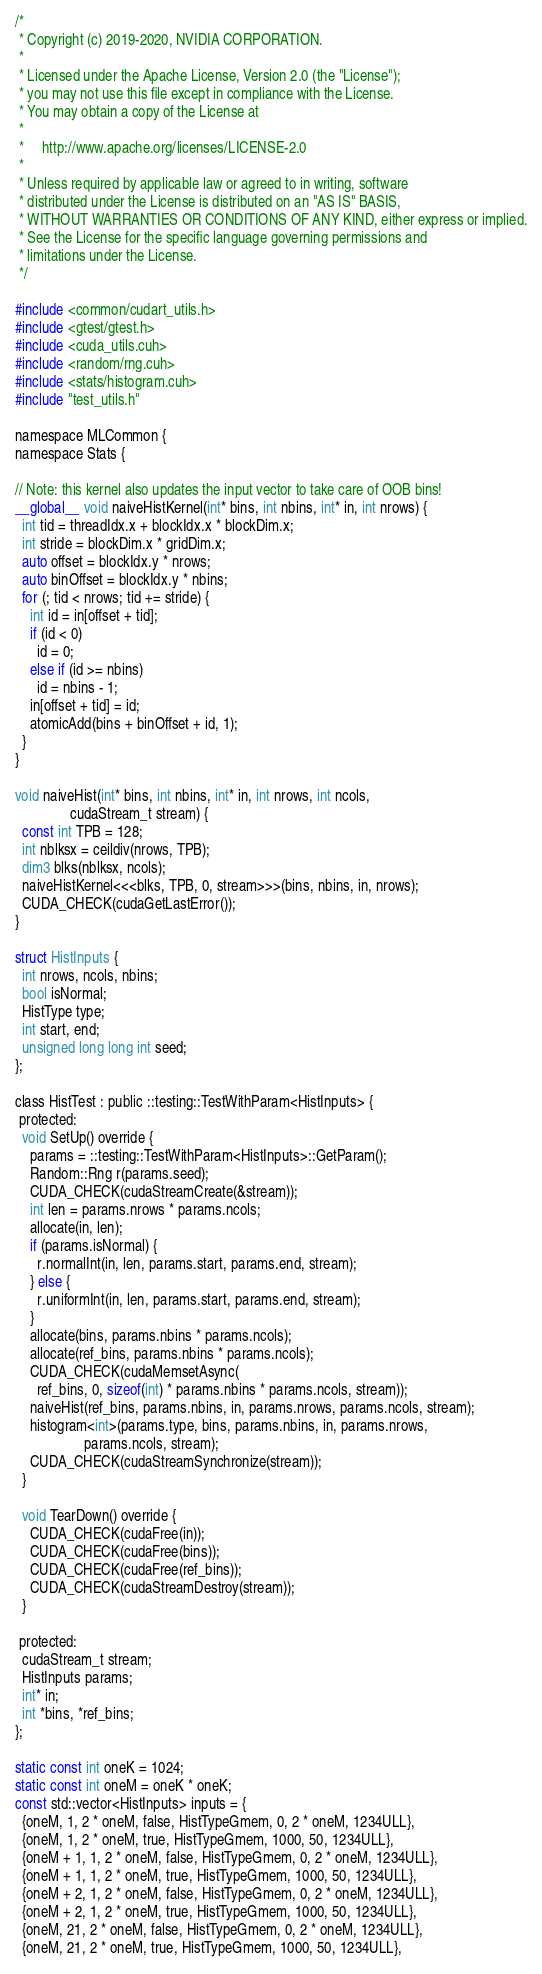Convert code to text. <code><loc_0><loc_0><loc_500><loc_500><_Cuda_>/*
 * Copyright (c) 2019-2020, NVIDIA CORPORATION.
 *
 * Licensed under the Apache License, Version 2.0 (the "License");
 * you may not use this file except in compliance with the License.
 * You may obtain a copy of the License at
 *
 *     http://www.apache.org/licenses/LICENSE-2.0
 *
 * Unless required by applicable law or agreed to in writing, software
 * distributed under the License is distributed on an "AS IS" BASIS,
 * WITHOUT WARRANTIES OR CONDITIONS OF ANY KIND, either express or implied.
 * See the License for the specific language governing permissions and
 * limitations under the License.
 */

#include <common/cudart_utils.h>
#include <gtest/gtest.h>
#include <cuda_utils.cuh>
#include <random/rng.cuh>
#include <stats/histogram.cuh>
#include "test_utils.h"

namespace MLCommon {
namespace Stats {

// Note: this kernel also updates the input vector to take care of OOB bins!
__global__ void naiveHistKernel(int* bins, int nbins, int* in, int nrows) {
  int tid = threadIdx.x + blockIdx.x * blockDim.x;
  int stride = blockDim.x * gridDim.x;
  auto offset = blockIdx.y * nrows;
  auto binOffset = blockIdx.y * nbins;
  for (; tid < nrows; tid += stride) {
    int id = in[offset + tid];
    if (id < 0)
      id = 0;
    else if (id >= nbins)
      id = nbins - 1;
    in[offset + tid] = id;
    atomicAdd(bins + binOffset + id, 1);
  }
}

void naiveHist(int* bins, int nbins, int* in, int nrows, int ncols,
               cudaStream_t stream) {
  const int TPB = 128;
  int nblksx = ceildiv(nrows, TPB);
  dim3 blks(nblksx, ncols);
  naiveHistKernel<<<blks, TPB, 0, stream>>>(bins, nbins, in, nrows);
  CUDA_CHECK(cudaGetLastError());
}

struct HistInputs {
  int nrows, ncols, nbins;
  bool isNormal;
  HistType type;
  int start, end;
  unsigned long long int seed;
};

class HistTest : public ::testing::TestWithParam<HistInputs> {
 protected:
  void SetUp() override {
    params = ::testing::TestWithParam<HistInputs>::GetParam();
    Random::Rng r(params.seed);
    CUDA_CHECK(cudaStreamCreate(&stream));
    int len = params.nrows * params.ncols;
    allocate(in, len);
    if (params.isNormal) {
      r.normalInt(in, len, params.start, params.end, stream);
    } else {
      r.uniformInt(in, len, params.start, params.end, stream);
    }
    allocate(bins, params.nbins * params.ncols);
    allocate(ref_bins, params.nbins * params.ncols);
    CUDA_CHECK(cudaMemsetAsync(
      ref_bins, 0, sizeof(int) * params.nbins * params.ncols, stream));
    naiveHist(ref_bins, params.nbins, in, params.nrows, params.ncols, stream);
    histogram<int>(params.type, bins, params.nbins, in, params.nrows,
                   params.ncols, stream);
    CUDA_CHECK(cudaStreamSynchronize(stream));
  }

  void TearDown() override {
    CUDA_CHECK(cudaFree(in));
    CUDA_CHECK(cudaFree(bins));
    CUDA_CHECK(cudaFree(ref_bins));
    CUDA_CHECK(cudaStreamDestroy(stream));
  }

 protected:
  cudaStream_t stream;
  HistInputs params;
  int* in;
  int *bins, *ref_bins;
};

static const int oneK = 1024;
static const int oneM = oneK * oneK;
const std::vector<HistInputs> inputs = {
  {oneM, 1, 2 * oneM, false, HistTypeGmem, 0, 2 * oneM, 1234ULL},
  {oneM, 1, 2 * oneM, true, HistTypeGmem, 1000, 50, 1234ULL},
  {oneM + 1, 1, 2 * oneM, false, HistTypeGmem, 0, 2 * oneM, 1234ULL},
  {oneM + 1, 1, 2 * oneM, true, HistTypeGmem, 1000, 50, 1234ULL},
  {oneM + 2, 1, 2 * oneM, false, HistTypeGmem, 0, 2 * oneM, 1234ULL},
  {oneM + 2, 1, 2 * oneM, true, HistTypeGmem, 1000, 50, 1234ULL},
  {oneM, 21, 2 * oneM, false, HistTypeGmem, 0, 2 * oneM, 1234ULL},
  {oneM, 21, 2 * oneM, true, HistTypeGmem, 1000, 50, 1234ULL},</code> 